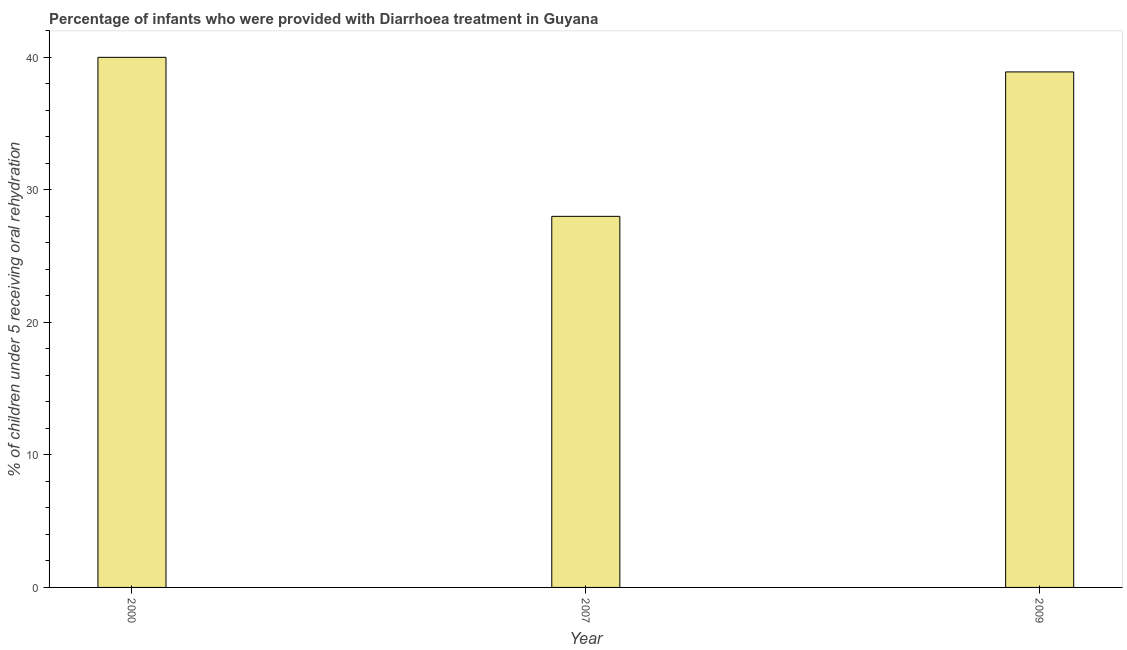Does the graph contain grids?
Your answer should be compact. No. What is the title of the graph?
Your answer should be very brief. Percentage of infants who were provided with Diarrhoea treatment in Guyana. What is the label or title of the X-axis?
Give a very brief answer. Year. What is the label or title of the Y-axis?
Your response must be concise. % of children under 5 receiving oral rehydration. What is the percentage of children who were provided with treatment diarrhoea in 2007?
Keep it short and to the point. 28. Across all years, what is the maximum percentage of children who were provided with treatment diarrhoea?
Make the answer very short. 40. In which year was the percentage of children who were provided with treatment diarrhoea maximum?
Keep it short and to the point. 2000. What is the sum of the percentage of children who were provided with treatment diarrhoea?
Your answer should be very brief. 106.9. What is the average percentage of children who were provided with treatment diarrhoea per year?
Your answer should be compact. 35.63. What is the median percentage of children who were provided with treatment diarrhoea?
Provide a succinct answer. 38.9. In how many years, is the percentage of children who were provided with treatment diarrhoea greater than 14 %?
Offer a very short reply. 3. What is the ratio of the percentage of children who were provided with treatment diarrhoea in 2007 to that in 2009?
Your response must be concise. 0.72. What is the difference between the highest and the lowest percentage of children who were provided with treatment diarrhoea?
Make the answer very short. 12. In how many years, is the percentage of children who were provided with treatment diarrhoea greater than the average percentage of children who were provided with treatment diarrhoea taken over all years?
Keep it short and to the point. 2. How many years are there in the graph?
Provide a succinct answer. 3. What is the % of children under 5 receiving oral rehydration in 2009?
Provide a succinct answer. 38.9. What is the difference between the % of children under 5 receiving oral rehydration in 2007 and 2009?
Keep it short and to the point. -10.9. What is the ratio of the % of children under 5 receiving oral rehydration in 2000 to that in 2007?
Your answer should be very brief. 1.43. What is the ratio of the % of children under 5 receiving oral rehydration in 2000 to that in 2009?
Give a very brief answer. 1.03. What is the ratio of the % of children under 5 receiving oral rehydration in 2007 to that in 2009?
Your response must be concise. 0.72. 